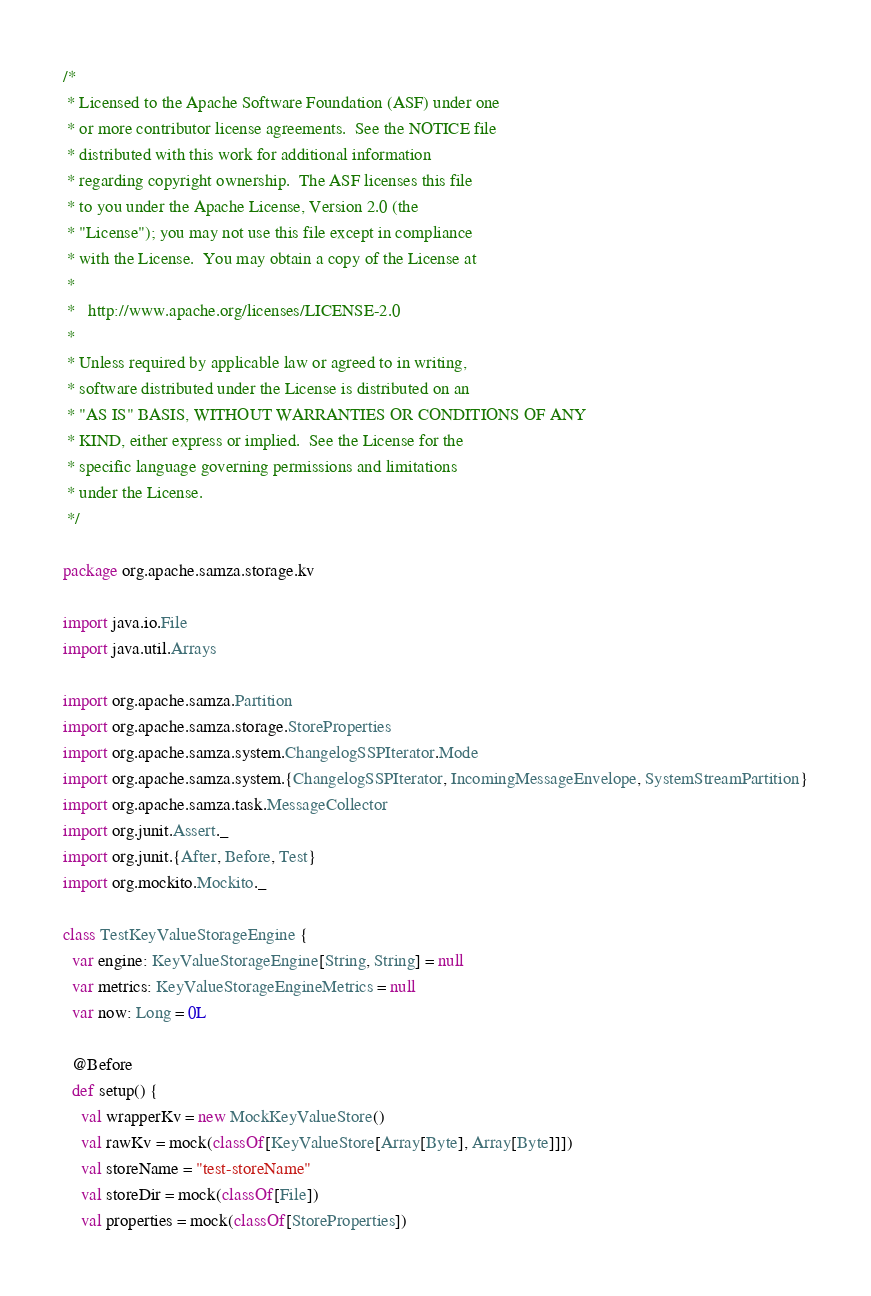<code> <loc_0><loc_0><loc_500><loc_500><_Scala_>/*
 * Licensed to the Apache Software Foundation (ASF) under one
 * or more contributor license agreements.  See the NOTICE file
 * distributed with this work for additional information
 * regarding copyright ownership.  The ASF licenses this file
 * to you under the Apache License, Version 2.0 (the
 * "License"); you may not use this file except in compliance
 * with the License.  You may obtain a copy of the License at
 *
 *   http://www.apache.org/licenses/LICENSE-2.0
 *
 * Unless required by applicable law or agreed to in writing,
 * software distributed under the License is distributed on an
 * "AS IS" BASIS, WITHOUT WARRANTIES OR CONDITIONS OF ANY
 * KIND, either express or implied.  See the License for the
 * specific language governing permissions and limitations
 * under the License.
 */

package org.apache.samza.storage.kv

import java.io.File
import java.util.Arrays

import org.apache.samza.Partition
import org.apache.samza.storage.StoreProperties
import org.apache.samza.system.ChangelogSSPIterator.Mode
import org.apache.samza.system.{ChangelogSSPIterator, IncomingMessageEnvelope, SystemStreamPartition}
import org.apache.samza.task.MessageCollector
import org.junit.Assert._
import org.junit.{After, Before, Test}
import org.mockito.Mockito._

class TestKeyValueStorageEngine {
  var engine: KeyValueStorageEngine[String, String] = null
  var metrics: KeyValueStorageEngineMetrics = null
  var now: Long = 0L

  @Before
  def setup() {
    val wrapperKv = new MockKeyValueStore()
    val rawKv = mock(classOf[KeyValueStore[Array[Byte], Array[Byte]]])
    val storeName = "test-storeName"
    val storeDir = mock(classOf[File])
    val properties = mock(classOf[StoreProperties])</code> 